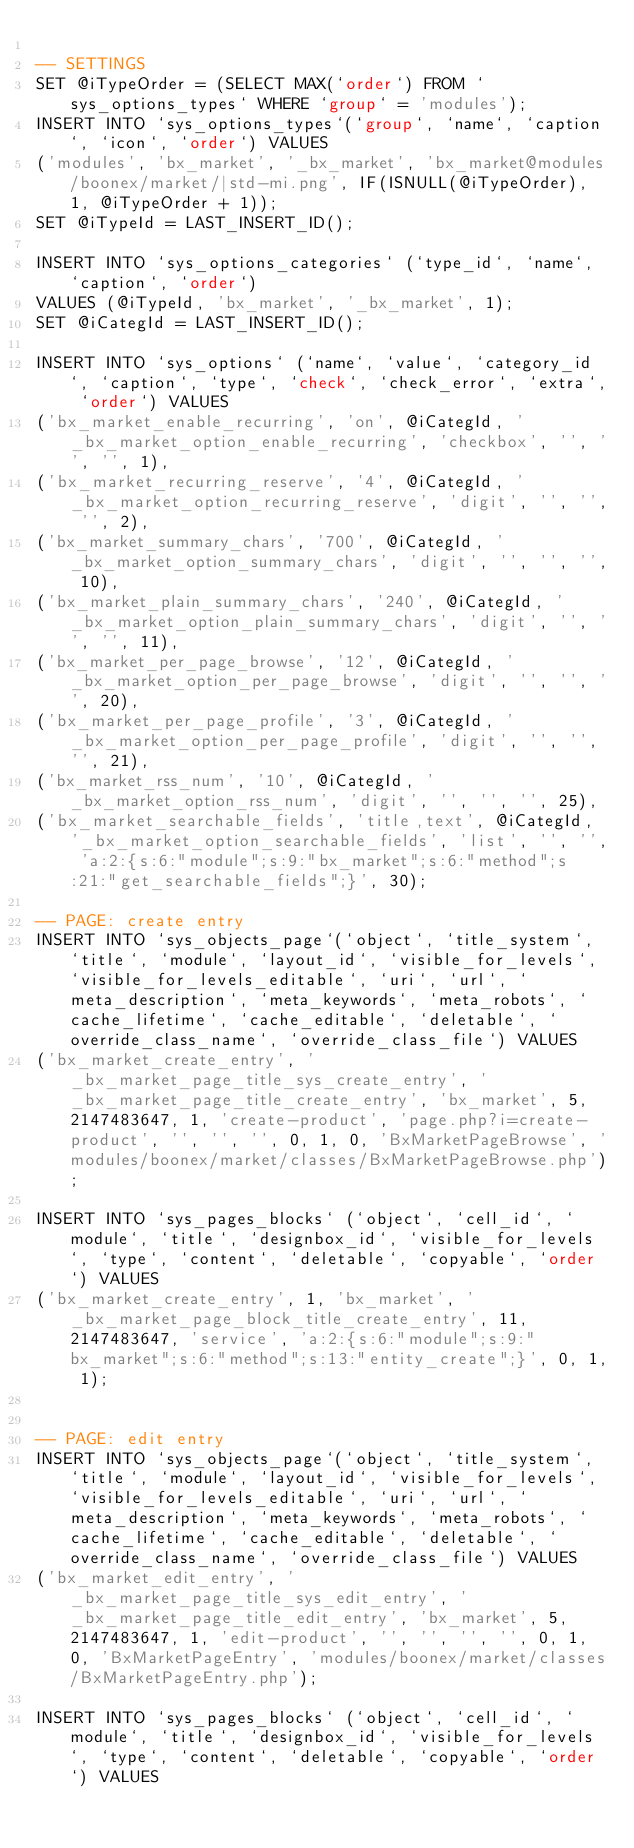<code> <loc_0><loc_0><loc_500><loc_500><_SQL_>
-- SETTINGS
SET @iTypeOrder = (SELECT MAX(`order`) FROM `sys_options_types` WHERE `group` = 'modules');
INSERT INTO `sys_options_types`(`group`, `name`, `caption`, `icon`, `order`) VALUES 
('modules', 'bx_market', '_bx_market', 'bx_market@modules/boonex/market/|std-mi.png', IF(ISNULL(@iTypeOrder), 1, @iTypeOrder + 1));
SET @iTypeId = LAST_INSERT_ID();

INSERT INTO `sys_options_categories` (`type_id`, `name`, `caption`, `order`)
VALUES (@iTypeId, 'bx_market', '_bx_market', 1);
SET @iCategId = LAST_INSERT_ID();

INSERT INTO `sys_options` (`name`, `value`, `category_id`, `caption`, `type`, `check`, `check_error`, `extra`, `order`) VALUES
('bx_market_enable_recurring', 'on', @iCategId, '_bx_market_option_enable_recurring', 'checkbox', '', '', '', 1),
('bx_market_recurring_reserve', '4', @iCategId, '_bx_market_option_recurring_reserve', 'digit', '', '', '', 2),
('bx_market_summary_chars', '700', @iCategId, '_bx_market_option_summary_chars', 'digit', '', '', '', 10),
('bx_market_plain_summary_chars', '240', @iCategId, '_bx_market_option_plain_summary_chars', 'digit', '', '', '', 11),
('bx_market_per_page_browse', '12', @iCategId, '_bx_market_option_per_page_browse', 'digit', '', '', '', 20),
('bx_market_per_page_profile', '3', @iCategId, '_bx_market_option_per_page_profile', 'digit', '', '', '', 21),
('bx_market_rss_num', '10', @iCategId, '_bx_market_option_rss_num', 'digit', '', '', '', 25),
('bx_market_searchable_fields', 'title,text', @iCategId, '_bx_market_option_searchable_fields', 'list', '', '', 'a:2:{s:6:"module";s:9:"bx_market";s:6:"method";s:21:"get_searchable_fields";}', 30);

-- PAGE: create entry
INSERT INTO `sys_objects_page`(`object`, `title_system`, `title`, `module`, `layout_id`, `visible_for_levels`, `visible_for_levels_editable`, `uri`, `url`, `meta_description`, `meta_keywords`, `meta_robots`, `cache_lifetime`, `cache_editable`, `deletable`, `override_class_name`, `override_class_file`) VALUES 
('bx_market_create_entry', '_bx_market_page_title_sys_create_entry', '_bx_market_page_title_create_entry', 'bx_market', 5, 2147483647, 1, 'create-product', 'page.php?i=create-product', '', '', '', 0, 1, 0, 'BxMarketPageBrowse', 'modules/boonex/market/classes/BxMarketPageBrowse.php');

INSERT INTO `sys_pages_blocks` (`object`, `cell_id`, `module`, `title`, `designbox_id`, `visible_for_levels`, `type`, `content`, `deletable`, `copyable`, `order`) VALUES
('bx_market_create_entry', 1, 'bx_market', '_bx_market_page_block_title_create_entry', 11, 2147483647, 'service', 'a:2:{s:6:"module";s:9:"bx_market";s:6:"method";s:13:"entity_create";}', 0, 1, 1);


-- PAGE: edit entry
INSERT INTO `sys_objects_page`(`object`, `title_system`, `title`, `module`, `layout_id`, `visible_for_levels`, `visible_for_levels_editable`, `uri`, `url`, `meta_description`, `meta_keywords`, `meta_robots`, `cache_lifetime`, `cache_editable`, `deletable`, `override_class_name`, `override_class_file`) VALUES 
('bx_market_edit_entry', '_bx_market_page_title_sys_edit_entry', '_bx_market_page_title_edit_entry', 'bx_market', 5, 2147483647, 1, 'edit-product', '', '', '', '', 0, 1, 0, 'BxMarketPageEntry', 'modules/boonex/market/classes/BxMarketPageEntry.php');

INSERT INTO `sys_pages_blocks` (`object`, `cell_id`, `module`, `title`, `designbox_id`, `visible_for_levels`, `type`, `content`, `deletable`, `copyable`, `order`) VALUES</code> 